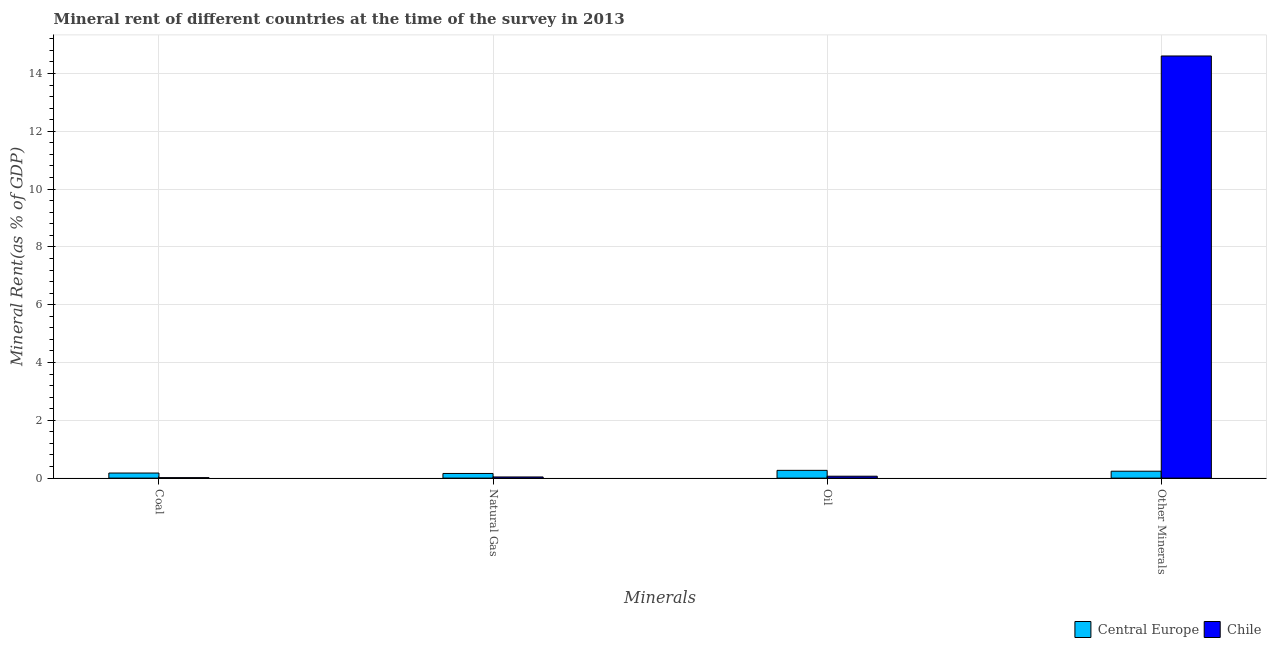How many different coloured bars are there?
Ensure brevity in your answer.  2. What is the label of the 1st group of bars from the left?
Your answer should be very brief. Coal. What is the coal rent in Chile?
Your response must be concise. 0.02. Across all countries, what is the maximum  rent of other minerals?
Your answer should be compact. 14.61. Across all countries, what is the minimum natural gas rent?
Provide a short and direct response. 0.04. In which country was the  rent of other minerals maximum?
Offer a very short reply. Chile. In which country was the oil rent minimum?
Your answer should be very brief. Chile. What is the total coal rent in the graph?
Offer a terse response. 0.19. What is the difference between the natural gas rent in Central Europe and that in Chile?
Offer a very short reply. 0.12. What is the difference between the natural gas rent in Chile and the coal rent in Central Europe?
Your answer should be compact. -0.14. What is the average  rent of other minerals per country?
Your answer should be very brief. 7.42. What is the difference between the natural gas rent and coal rent in Chile?
Provide a short and direct response. 0.02. In how many countries, is the natural gas rent greater than 9.6 %?
Keep it short and to the point. 0. What is the ratio of the natural gas rent in Central Europe to that in Chile?
Your answer should be compact. 4.03. Is the coal rent in Central Europe less than that in Chile?
Provide a succinct answer. No. What is the difference between the highest and the second highest  rent of other minerals?
Provide a short and direct response. 14.37. What is the difference between the highest and the lowest  rent of other minerals?
Offer a very short reply. 14.37. In how many countries, is the coal rent greater than the average coal rent taken over all countries?
Make the answer very short. 1. Is it the case that in every country, the sum of the coal rent and  rent of other minerals is greater than the sum of natural gas rent and oil rent?
Your answer should be very brief. No. What does the 1st bar from the left in Other Minerals represents?
Keep it short and to the point. Central Europe. How many bars are there?
Keep it short and to the point. 8. How many countries are there in the graph?
Your answer should be compact. 2. Are the values on the major ticks of Y-axis written in scientific E-notation?
Give a very brief answer. No. Where does the legend appear in the graph?
Keep it short and to the point. Bottom right. What is the title of the graph?
Your answer should be compact. Mineral rent of different countries at the time of the survey in 2013. Does "Central African Republic" appear as one of the legend labels in the graph?
Your response must be concise. No. What is the label or title of the X-axis?
Ensure brevity in your answer.  Minerals. What is the label or title of the Y-axis?
Offer a terse response. Mineral Rent(as % of GDP). What is the Mineral Rent(as % of GDP) in Central Europe in Coal?
Provide a succinct answer. 0.18. What is the Mineral Rent(as % of GDP) in Chile in Coal?
Provide a short and direct response. 0.02. What is the Mineral Rent(as % of GDP) of Central Europe in Natural Gas?
Ensure brevity in your answer.  0.16. What is the Mineral Rent(as % of GDP) of Chile in Natural Gas?
Keep it short and to the point. 0.04. What is the Mineral Rent(as % of GDP) in Central Europe in Oil?
Your answer should be compact. 0.27. What is the Mineral Rent(as % of GDP) in Chile in Oil?
Offer a terse response. 0.07. What is the Mineral Rent(as % of GDP) of Central Europe in Other Minerals?
Give a very brief answer. 0.24. What is the Mineral Rent(as % of GDP) in Chile in Other Minerals?
Offer a terse response. 14.61. Across all Minerals, what is the maximum Mineral Rent(as % of GDP) in Central Europe?
Make the answer very short. 0.27. Across all Minerals, what is the maximum Mineral Rent(as % of GDP) in Chile?
Ensure brevity in your answer.  14.61. Across all Minerals, what is the minimum Mineral Rent(as % of GDP) in Central Europe?
Provide a short and direct response. 0.16. Across all Minerals, what is the minimum Mineral Rent(as % of GDP) of Chile?
Provide a succinct answer. 0.02. What is the total Mineral Rent(as % of GDP) of Central Europe in the graph?
Ensure brevity in your answer.  0.84. What is the total Mineral Rent(as % of GDP) in Chile in the graph?
Keep it short and to the point. 14.73. What is the difference between the Mineral Rent(as % of GDP) of Central Europe in Coal and that in Natural Gas?
Your answer should be very brief. 0.01. What is the difference between the Mineral Rent(as % of GDP) in Chile in Coal and that in Natural Gas?
Offer a terse response. -0.02. What is the difference between the Mineral Rent(as % of GDP) in Central Europe in Coal and that in Oil?
Keep it short and to the point. -0.09. What is the difference between the Mineral Rent(as % of GDP) in Chile in Coal and that in Oil?
Offer a very short reply. -0.05. What is the difference between the Mineral Rent(as % of GDP) of Central Europe in Coal and that in Other Minerals?
Your answer should be very brief. -0.06. What is the difference between the Mineral Rent(as % of GDP) in Chile in Coal and that in Other Minerals?
Offer a very short reply. -14.59. What is the difference between the Mineral Rent(as % of GDP) in Central Europe in Natural Gas and that in Oil?
Provide a short and direct response. -0.11. What is the difference between the Mineral Rent(as % of GDP) of Chile in Natural Gas and that in Oil?
Provide a short and direct response. -0.03. What is the difference between the Mineral Rent(as % of GDP) of Central Europe in Natural Gas and that in Other Minerals?
Make the answer very short. -0.08. What is the difference between the Mineral Rent(as % of GDP) of Chile in Natural Gas and that in Other Minerals?
Your answer should be very brief. -14.57. What is the difference between the Mineral Rent(as % of GDP) in Central Europe in Oil and that in Other Minerals?
Your response must be concise. 0.03. What is the difference between the Mineral Rent(as % of GDP) in Chile in Oil and that in Other Minerals?
Make the answer very short. -14.54. What is the difference between the Mineral Rent(as % of GDP) in Central Europe in Coal and the Mineral Rent(as % of GDP) in Chile in Natural Gas?
Ensure brevity in your answer.  0.14. What is the difference between the Mineral Rent(as % of GDP) of Central Europe in Coal and the Mineral Rent(as % of GDP) of Chile in Oil?
Provide a short and direct response. 0.11. What is the difference between the Mineral Rent(as % of GDP) in Central Europe in Coal and the Mineral Rent(as % of GDP) in Chile in Other Minerals?
Provide a short and direct response. -14.43. What is the difference between the Mineral Rent(as % of GDP) in Central Europe in Natural Gas and the Mineral Rent(as % of GDP) in Chile in Oil?
Provide a short and direct response. 0.1. What is the difference between the Mineral Rent(as % of GDP) in Central Europe in Natural Gas and the Mineral Rent(as % of GDP) in Chile in Other Minerals?
Offer a very short reply. -14.44. What is the difference between the Mineral Rent(as % of GDP) of Central Europe in Oil and the Mineral Rent(as % of GDP) of Chile in Other Minerals?
Your answer should be very brief. -14.34. What is the average Mineral Rent(as % of GDP) in Central Europe per Minerals?
Provide a short and direct response. 0.21. What is the average Mineral Rent(as % of GDP) in Chile per Minerals?
Ensure brevity in your answer.  3.68. What is the difference between the Mineral Rent(as % of GDP) of Central Europe and Mineral Rent(as % of GDP) of Chile in Coal?
Give a very brief answer. 0.16. What is the difference between the Mineral Rent(as % of GDP) of Central Europe and Mineral Rent(as % of GDP) of Chile in Natural Gas?
Make the answer very short. 0.12. What is the difference between the Mineral Rent(as % of GDP) in Central Europe and Mineral Rent(as % of GDP) in Chile in Oil?
Offer a very short reply. 0.2. What is the difference between the Mineral Rent(as % of GDP) of Central Europe and Mineral Rent(as % of GDP) of Chile in Other Minerals?
Provide a short and direct response. -14.37. What is the ratio of the Mineral Rent(as % of GDP) of Central Europe in Coal to that in Natural Gas?
Provide a succinct answer. 1.09. What is the ratio of the Mineral Rent(as % of GDP) of Chile in Coal to that in Natural Gas?
Offer a terse response. 0.4. What is the ratio of the Mineral Rent(as % of GDP) of Central Europe in Coal to that in Oil?
Ensure brevity in your answer.  0.65. What is the ratio of the Mineral Rent(as % of GDP) in Chile in Coal to that in Oil?
Give a very brief answer. 0.24. What is the ratio of the Mineral Rent(as % of GDP) in Central Europe in Coal to that in Other Minerals?
Provide a short and direct response. 0.74. What is the ratio of the Mineral Rent(as % of GDP) of Chile in Coal to that in Other Minerals?
Your answer should be very brief. 0. What is the ratio of the Mineral Rent(as % of GDP) of Central Europe in Natural Gas to that in Oil?
Your answer should be very brief. 0.6. What is the ratio of the Mineral Rent(as % of GDP) in Chile in Natural Gas to that in Oil?
Keep it short and to the point. 0.61. What is the ratio of the Mineral Rent(as % of GDP) in Central Europe in Natural Gas to that in Other Minerals?
Offer a terse response. 0.67. What is the ratio of the Mineral Rent(as % of GDP) in Chile in Natural Gas to that in Other Minerals?
Provide a succinct answer. 0. What is the ratio of the Mineral Rent(as % of GDP) of Central Europe in Oil to that in Other Minerals?
Your response must be concise. 1.12. What is the ratio of the Mineral Rent(as % of GDP) in Chile in Oil to that in Other Minerals?
Your answer should be compact. 0. What is the difference between the highest and the second highest Mineral Rent(as % of GDP) of Central Europe?
Make the answer very short. 0.03. What is the difference between the highest and the second highest Mineral Rent(as % of GDP) in Chile?
Make the answer very short. 14.54. What is the difference between the highest and the lowest Mineral Rent(as % of GDP) of Central Europe?
Offer a terse response. 0.11. What is the difference between the highest and the lowest Mineral Rent(as % of GDP) in Chile?
Your answer should be compact. 14.59. 